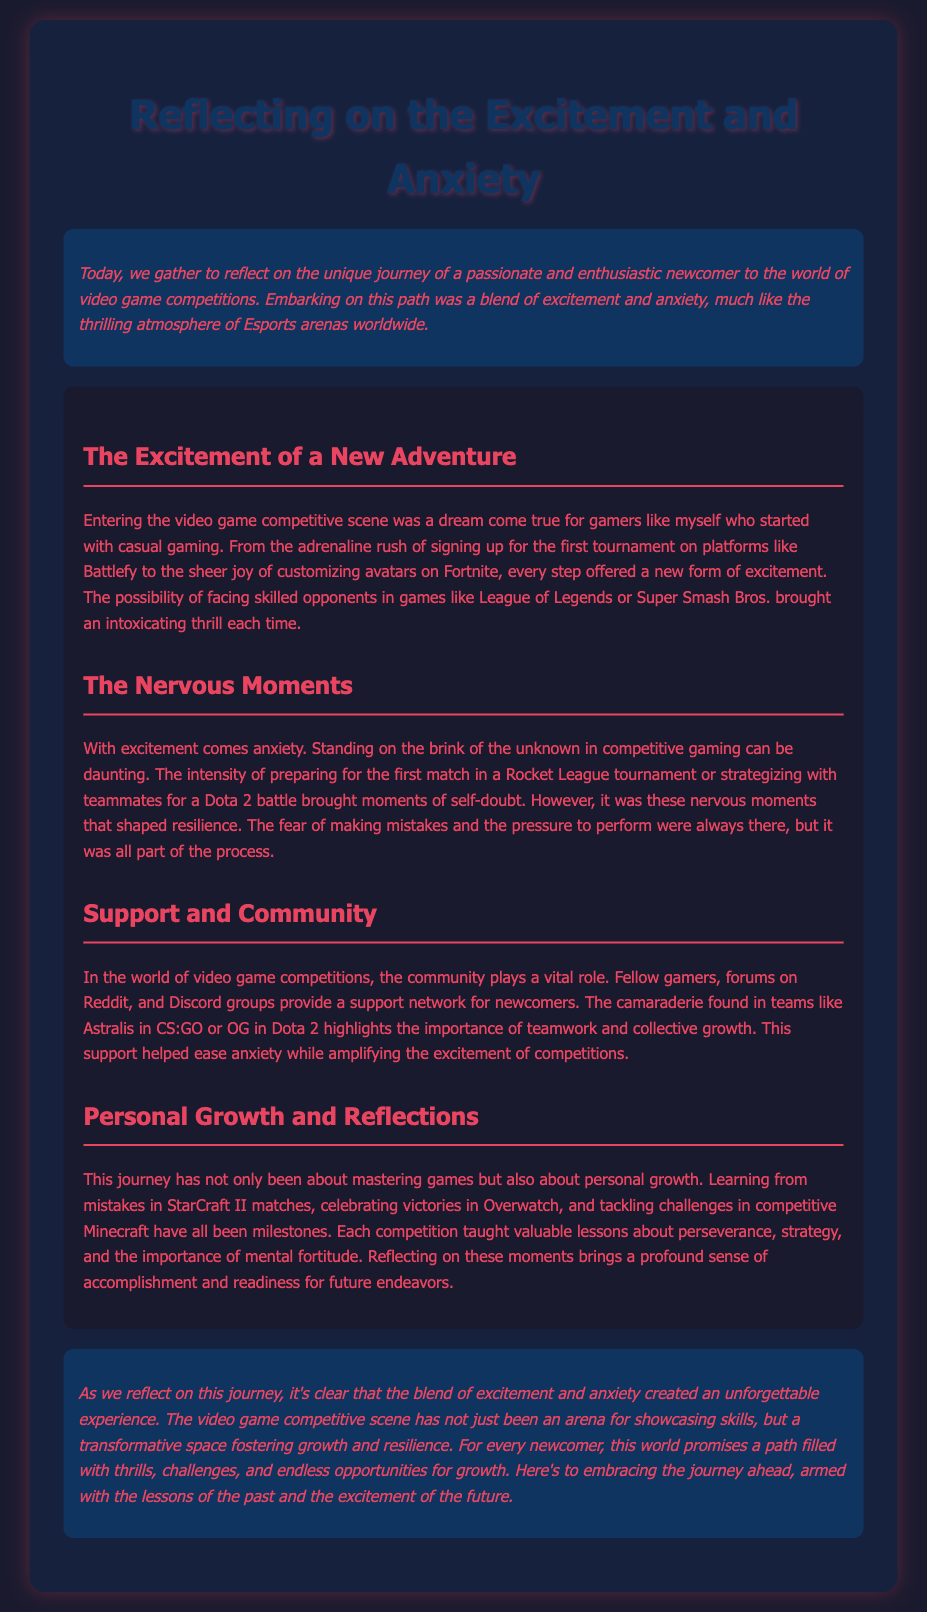What is the main theme of the document? The document reflects on the journey of a newcomer in video game competitions, focusing on their feelings of excitement and anxiety.
Answer: Excitement and anxiety Which platforms are mentioned for signing up for tournaments? The document mentions Battlefy as a platform for signing up for tournaments.
Answer: Battlefy What emotions are described in relation to entering the competitive scene? The document states that the emotions felt are excitement and anxiety when entering the competitive scene.
Answer: Excitement and anxiety What games are mentioned as examples of competitions? The document lists games such as League of Legends, Super Smash Bros., Rocket League, Dota 2, StarCraft II, Overwatch, and Minecraft.
Answer: League of Legends, Super Smash Bros., Rocket League, Dota 2, StarCraft II, Overwatch, Minecraft What role does the community play for newcomers? The community provides a support network for newcomers in the competitive gaming arena.
Answer: Support network What is highlighted as important in team dynamics? The importance of teamwork and collective growth is highlighted in team dynamics within the document.
Answer: Teamwork and collective growth What has this journey taught the newcomer? The journey has taught valuable lessons about perseverance, strategy, and mental fortitude.
Answer: Perseverance, strategy, mental fortitude What sentiment does the document conclude with regarding future endeavors? The conclusion expresses a positive sentiment about embracing future journeys filled with excitement.
Answer: Embracing the journey ahead 